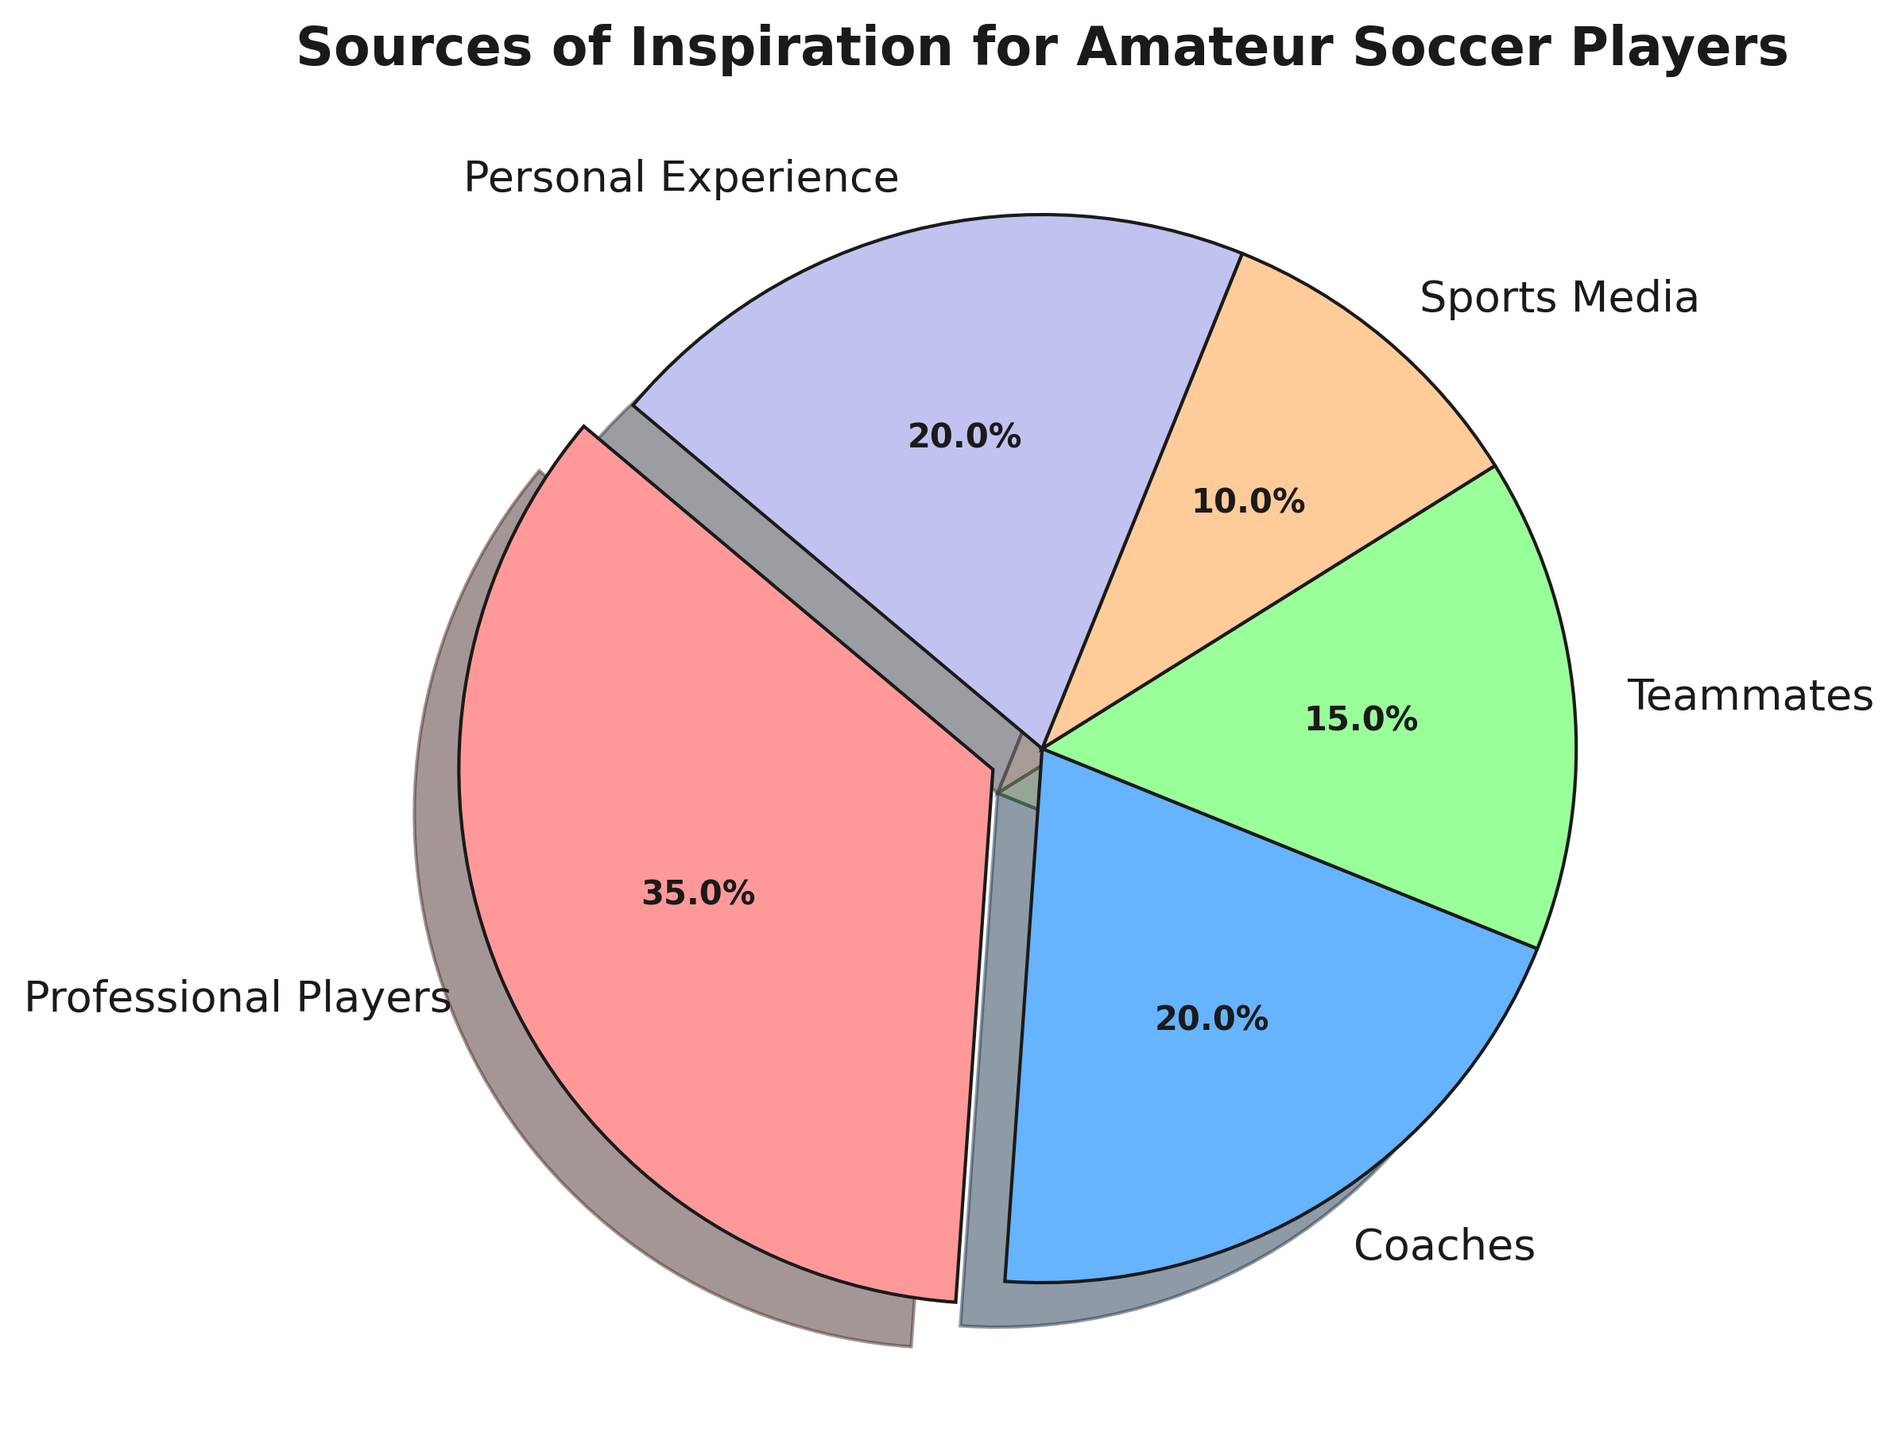Which source of inspiration for amateur soccer players has the highest percentage? The pie chart indicates different sources of inspiration and shows their respective percentages. The title "Sources of Inspiration for Amateur Soccer Players" helps contextually. Glancing at the slices, Professional Players occupy the largest portion.
Answer: Professional Players How does the combined percentage of Coaches and Personal Experience compare to Professional Players? First, find the individual percentages for Coaches (20%) and Personal Experience (20%). Sum them: \(20\% + 20\% = 40\%\). Compare this to Professional Players' 35%. The combined percentage of Coaches and Personal Experience is greater.
Answer: 40% is greater than 35% Which source of inspiration has the smallest percentage in the pie chart? The smallest percentage slice in the chart corresponds to the label Sports Media. This portion is visibly the smallest and is marked with a 10% label.
Answer: Sports Media How much larger is the percentage for Professional Players than for Teammates? Find the respective percentages for Professional Players (35%) and Teammates (15%). Calculate the difference: \(35\% - 15\% = 20\%\).
Answer: 20% List the sources of inspiration categorized as having a 20% share. Identify the slices with 20% labels in the pie chart. Both Coaches and Personal Experience are labeled with 20%.
Answer: Coaches, Personal Experience Compare the pie chart's green and orange sections. What can you infer? The green section is labeled Teammates with 15%, and the orange section is labeled Sports Media with 10%. The green section (Teammates) is larger than the orange section (Sports Media).
Answer: Teammates' percentage is higher than Sports Media's Which colors represent the sources Professional Players and Coaches, respectively? The pie chart uses specific colors for each source. Professional Players is shown with the largest slice which is red, and Coaches are represented with a somewhat smaller slice which is blue.
Answer: Red for Professional Players, Blue for Coaches What percentage of inspiration sources are labeled as having a 20% share in total? Both Coaches and Personal Experience sources are labeled with 20% shares. Sum them up: \(20\%\text{(Coaches)} + 20\%\text{(Personal Experience)} = 40\%\).
Answer: 40% 